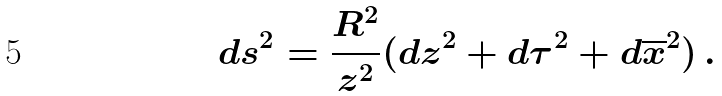<formula> <loc_0><loc_0><loc_500><loc_500>d s ^ { 2 } = \frac { R ^ { 2 } } { z ^ { 2 } } ( d z ^ { 2 } + d \tau ^ { 2 } + d \overline { x } ^ { 2 } ) \, .</formula> 